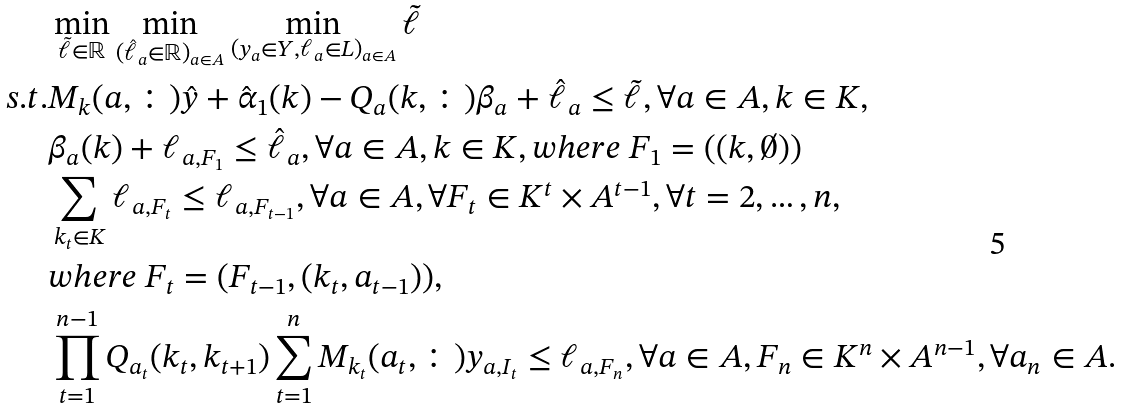Convert formula to latex. <formula><loc_0><loc_0><loc_500><loc_500>& \min _ { \tilde { \ell } \in \mathbb { R } } \min _ { ( \hat { \ell } _ { a } \in \mathbb { R } ) _ { a \in A } } \min _ { ( y _ { a } \in Y , \ell _ { a } \in L ) _ { a \in A } } \tilde { \ell } \\ s . t . & M _ { k } ( a , \colon ) \hat { y } + \hat { \alpha } _ { 1 } ( k ) - Q _ { a } ( k , \colon ) \beta _ { a } + \hat { \ell } _ { a } \leq \tilde { \ell } , \forall a \in A , k \in K , \\ & \beta _ { a } ( k ) + \ell _ { a , F _ { 1 } } \leq \hat { \ell } _ { a } , \forall a \in A , k \in K , w h e r e \ F _ { 1 } = ( ( k , \emptyset ) ) \\ & \sum _ { k _ { t } \in K } \ell _ { a , F _ { t } } \leq \ell _ { a , F _ { t - 1 } } , \forall a \in A , \forall F _ { t } \in K ^ { t } \times A ^ { t - 1 } , \forall t = 2 , \dots , n , \\ & w h e r e \ F _ { t } = ( F _ { t - 1 } , ( k _ { t } , a _ { t - 1 } ) ) , \\ & \prod _ { t = 1 } ^ { n - 1 } Q _ { a _ { t } } ( k _ { t } , k _ { t + 1 } ) \sum _ { t = 1 } ^ { n } M _ { k _ { t } } ( a _ { t } , \colon ) y _ { a , I _ { t } } \leq \ell _ { a , F _ { n } } , \forall a \in A , F _ { n } \in K ^ { n } \times A ^ { n - 1 } , \forall a _ { n } \in A .</formula> 